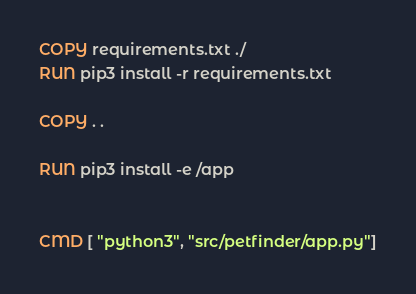<code> <loc_0><loc_0><loc_500><loc_500><_Dockerfile_>COPY requirements.txt ./
RUN pip3 install -r requirements.txt

COPY . .

RUN pip3 install -e /app


CMD [ "python3", "src/petfinder/app.py"]</code> 